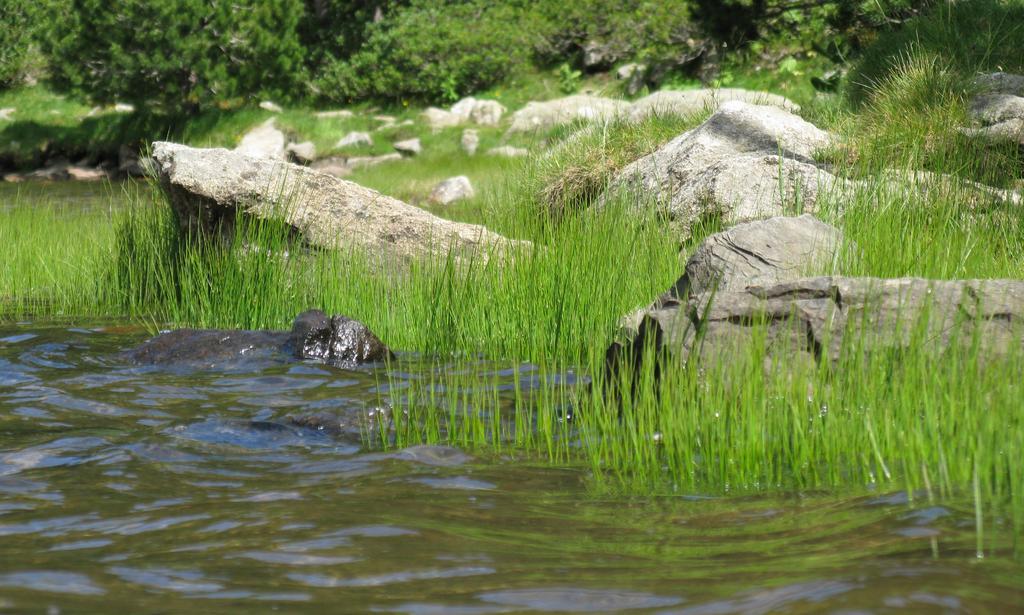Please provide a concise description of this image. There is an animal in the water near grass and rocks on the ground. In the background, there are plants and trees. 